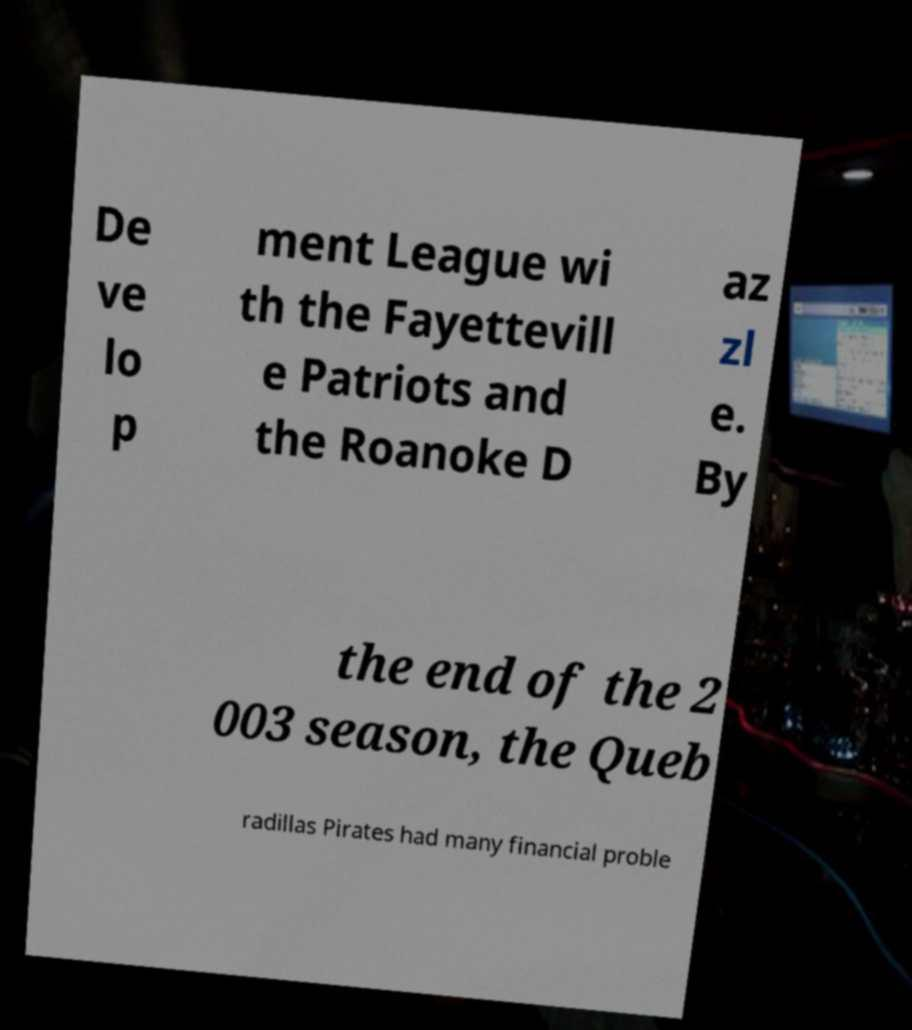There's text embedded in this image that I need extracted. Can you transcribe it verbatim? De ve lo p ment League wi th the Fayettevill e Patriots and the Roanoke D az zl e. By the end of the 2 003 season, the Queb radillas Pirates had many financial proble 